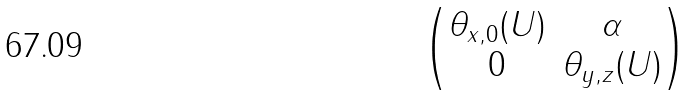Convert formula to latex. <formula><loc_0><loc_0><loc_500><loc_500>\begin{pmatrix} \theta _ { x , 0 } ( U ) & \alpha \\ 0 & \theta _ { y , z } ( U ) \end{pmatrix}</formula> 